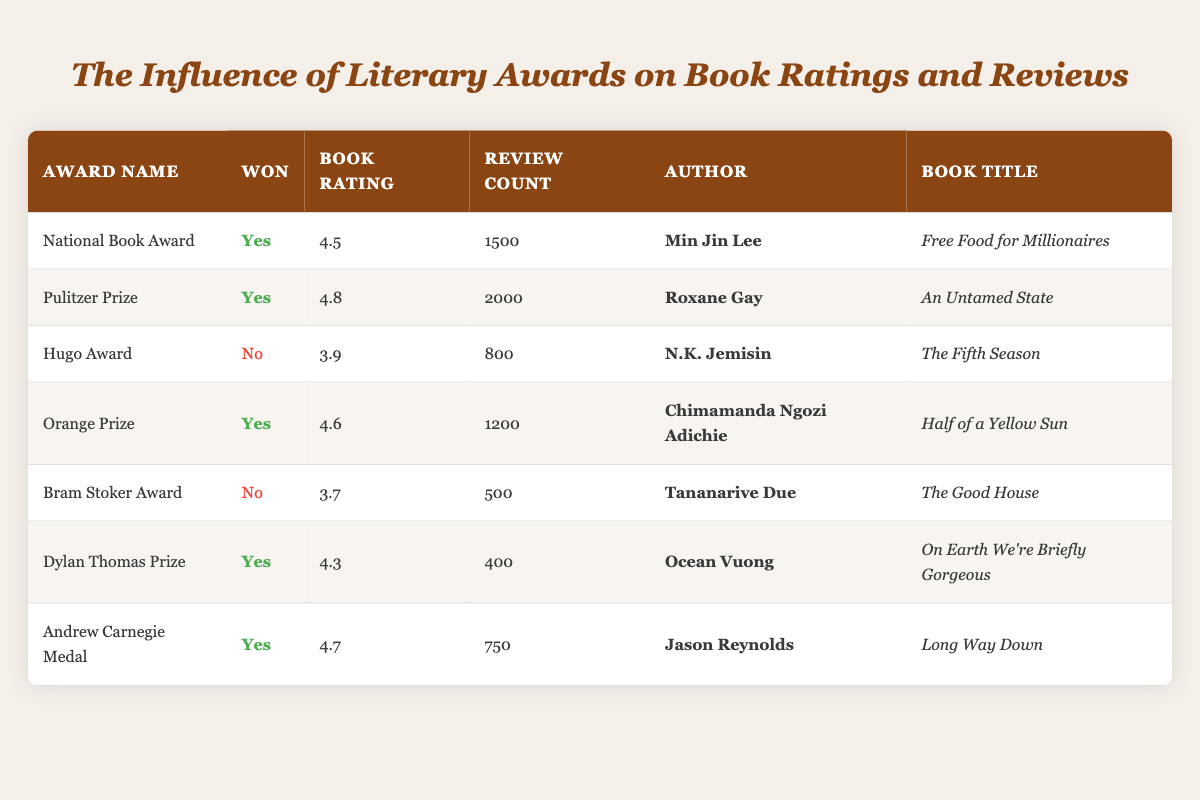What is the highest book rating among the awarded books? The awarded books are "Free Food for Millionaires" (4.5), "An Untamed State" (4.8), "Half of a Yellow Sun" (4.6), "On Earth We're Briefly Gorgeous" (4.3), and "Long Way Down" (4.7). Among these, 4.8 is the highest rating from "An Untamed State" by Roxane Gay.
Answer: 4.8 How many books in the table won an award? The books that won awards are "Free Food for Millionaires," "An Untamed State," "Half of a Yellow Sun," "On Earth We're Briefly Gorgeous," and "Long Way Down." There are 5 books that won awards in total.
Answer: 5 What is the average review count of the books that did not win any awards? The books that did not win awards are "The Fifth Season" (800 reviews) and "The Good House" (500 reviews). Their review counts are 800 and 500 respectively, giving a total of (800 + 500) = 1300. The average is 1300 divided by 2, which equals 650.
Answer: 650 Which author has the most reviews for their awarded book? The awarded books and their review counts are: "Free Food for Millionaires" (1500), "An Untamed State" (2000), "Half of a Yellow Sun" (1200), "On Earth We're Briefly Gorgeous" (400), and "Long Way Down" (750). "An Untamed State" by Roxane Gay has the most reviews with 2000.
Answer: Roxane Gay Is there a correlation between winning a literary award and having a book rating of 4.5 or above? Yes, all awarded books have book ratings of 4.5 or above (4.5, 4.8, 4.6, 4.3, and 4.7), while books that did not win awards have ratings below 4.5 (3.9 and 3.7). Hence, winning an award seems to influence having a higher book rating.
Answer: Yes 